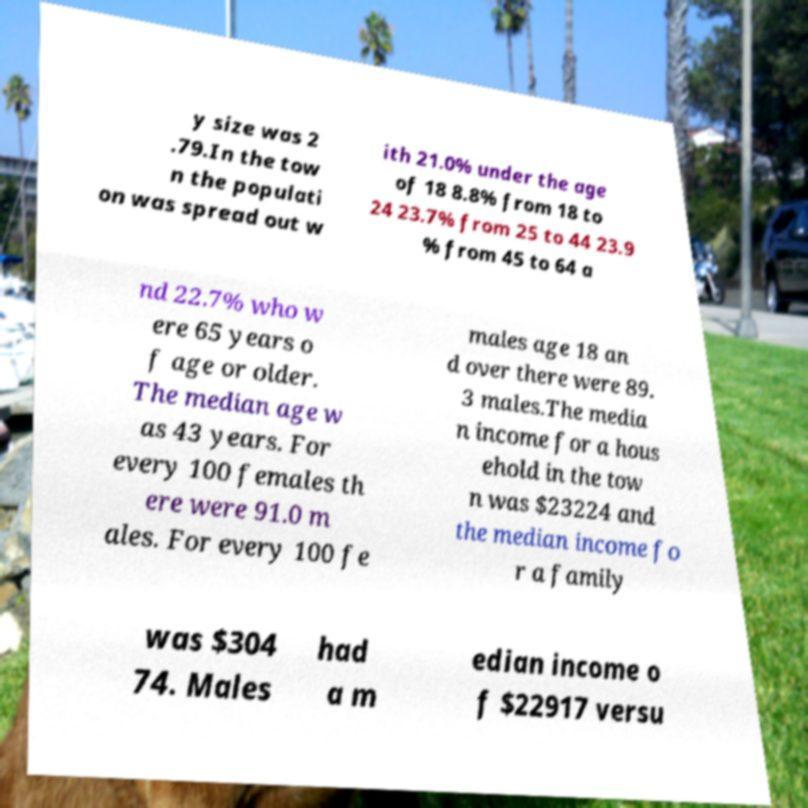Please read and relay the text visible in this image. What does it say? y size was 2 .79.In the tow n the populati on was spread out w ith 21.0% under the age of 18 8.8% from 18 to 24 23.7% from 25 to 44 23.9 % from 45 to 64 a nd 22.7% who w ere 65 years o f age or older. The median age w as 43 years. For every 100 females th ere were 91.0 m ales. For every 100 fe males age 18 an d over there were 89. 3 males.The media n income for a hous ehold in the tow n was $23224 and the median income fo r a family was $304 74. Males had a m edian income o f $22917 versu 